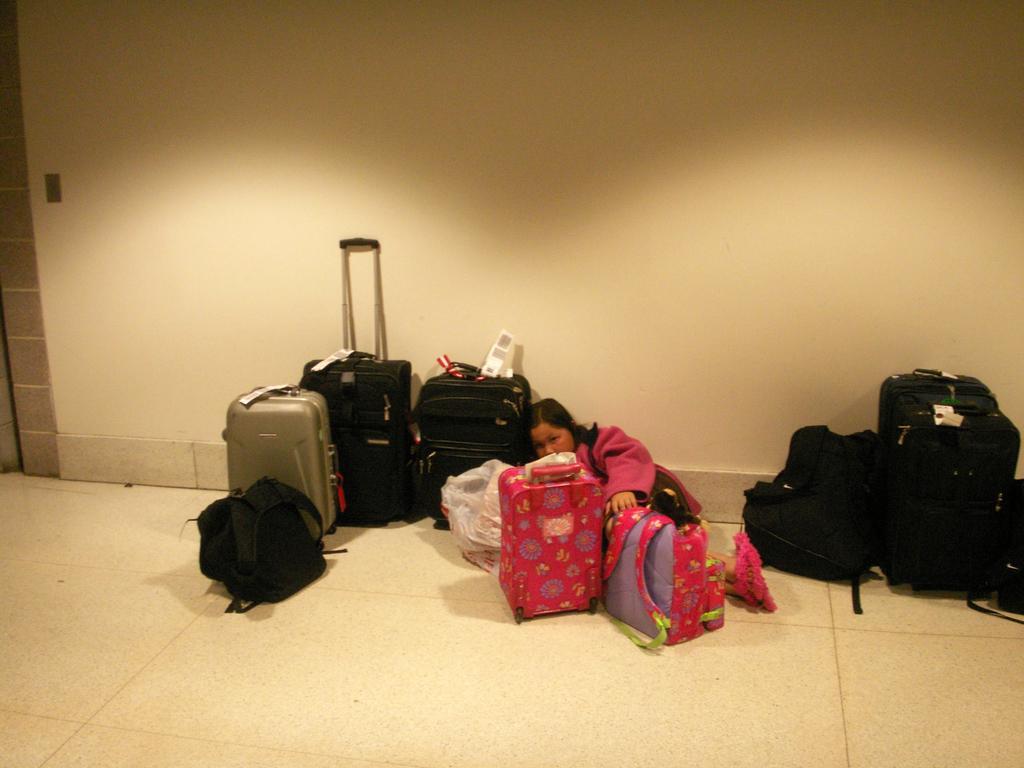Describe this image in one or two sentences. In this there are group of bags placed besides a wall, towards the right corner there are four bags which are in black in color. In the center there are two pink bags. In the right there three bags and one grey bag. In between the bags there is the person, she is wearing a pink dress. In the background there is a wall. 